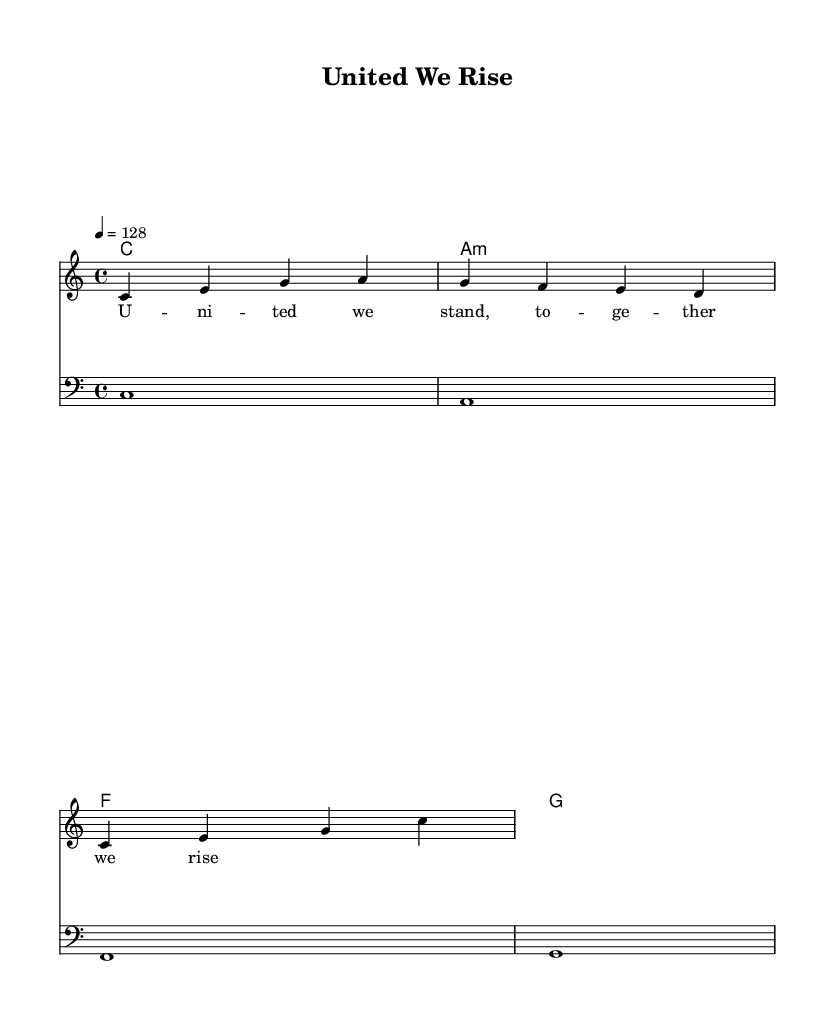What is the title of this piece? The title of the piece is indicated in the header section of the sheet music. It reads "United We Rise."
Answer: United We Rise What is the time signature of this music? The time signature is found at the beginning of the staff and is marked as 4/4, indicating there are four beats in each measure.
Answer: 4/4 What is the tempo marking in this score? The tempo marking is shown after the time signature and is noted as 4 equals 128, which is the metronome marking for the piece.
Answer: 128 How many different chords are used in the harmonies? The harmonies section contains four distinct chords: C, A minor, F, and G. By counting these chords, we determine the total.
Answer: Four What is the clef used for the bassline? The clef for the bassline is specified at the beginning of the bass staff, and it is indicated as the bass clef.
Answer: Bass clef In which key is this composition? The key signature is indicated at the beginning and is noted as C major, which is characterized by having no sharps or flats.
Answer: C major What is the main theme expressed in the lyrics? The lyrics signify unity and support, as inferred from the phrase “United we stand, together we rise,” highlighting the theme of teamwork and perseverance.
Answer: Unity 